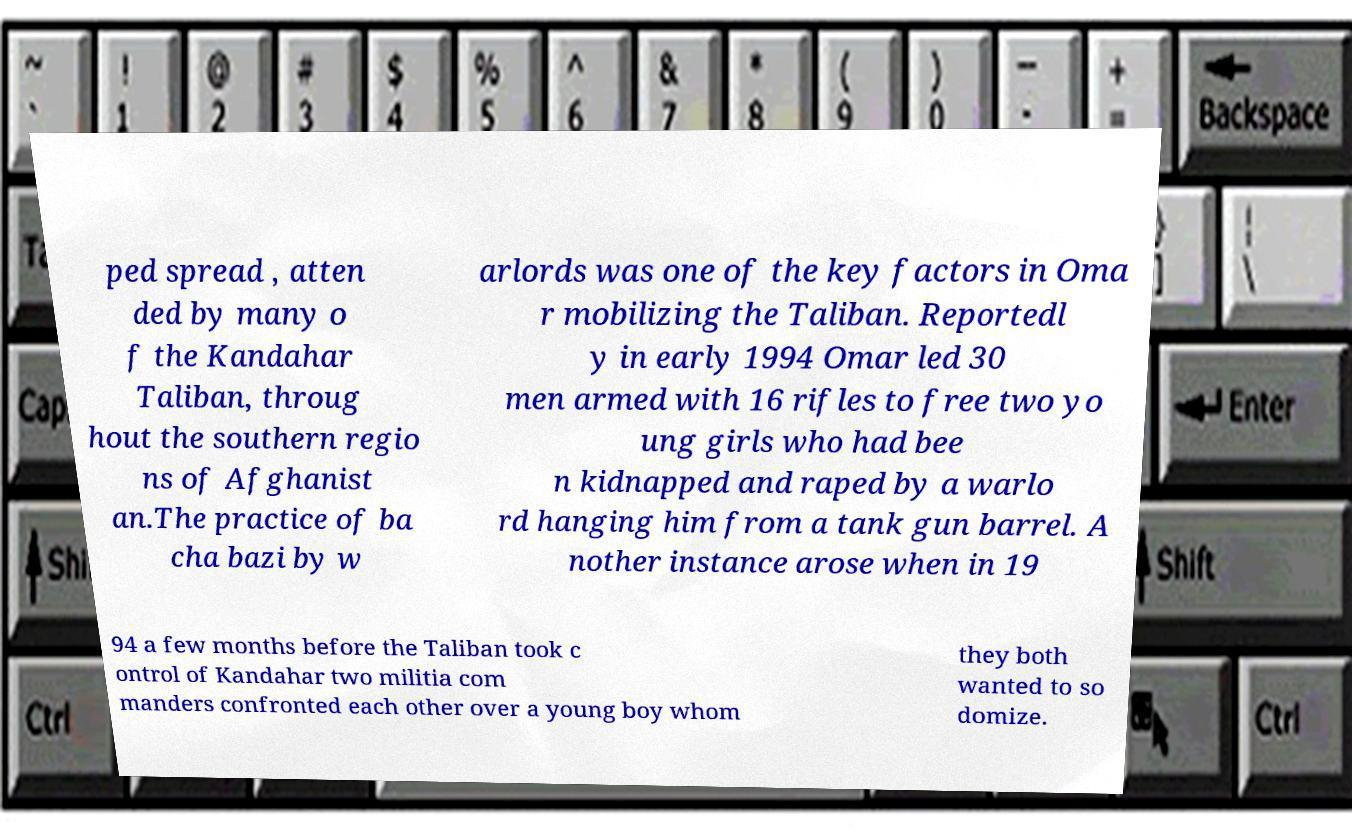I need the written content from this picture converted into text. Can you do that? ped spread , atten ded by many o f the Kandahar Taliban, throug hout the southern regio ns of Afghanist an.The practice of ba cha bazi by w arlords was one of the key factors in Oma r mobilizing the Taliban. Reportedl y in early 1994 Omar led 30 men armed with 16 rifles to free two yo ung girls who had bee n kidnapped and raped by a warlo rd hanging him from a tank gun barrel. A nother instance arose when in 19 94 a few months before the Taliban took c ontrol of Kandahar two militia com manders confronted each other over a young boy whom they both wanted to so domize. 